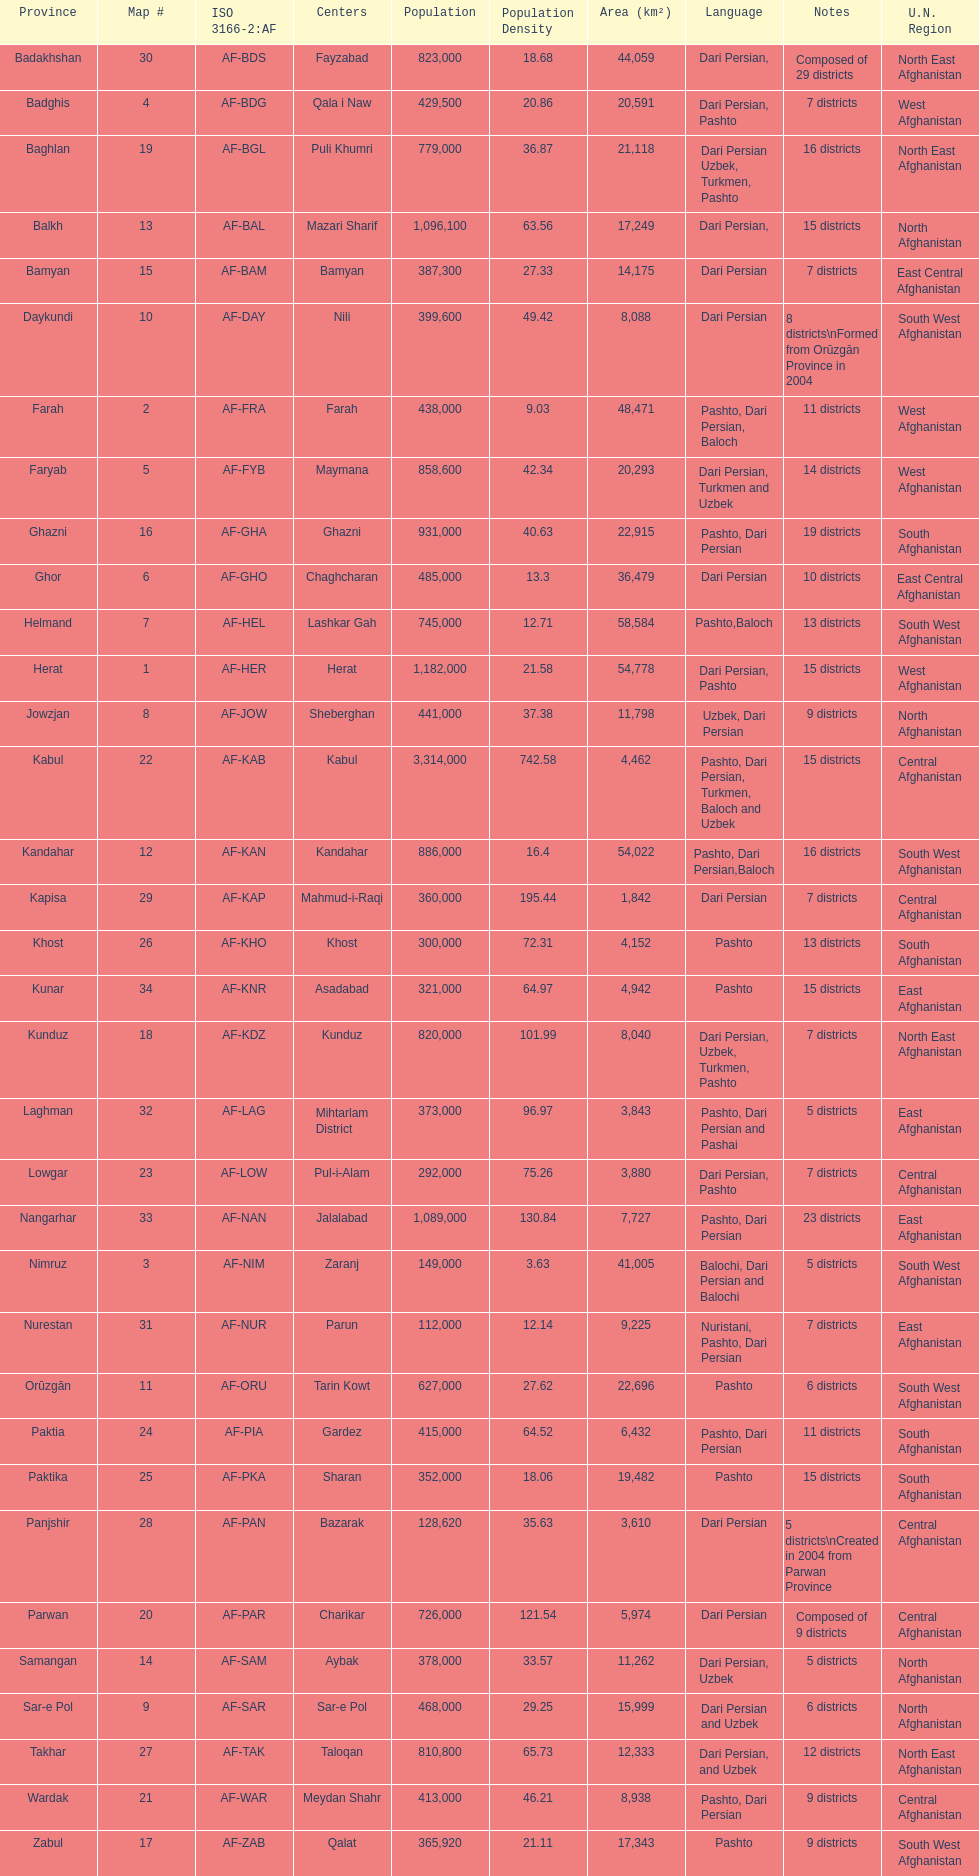What province in afghanistanhas the greatest population? Kabul. 